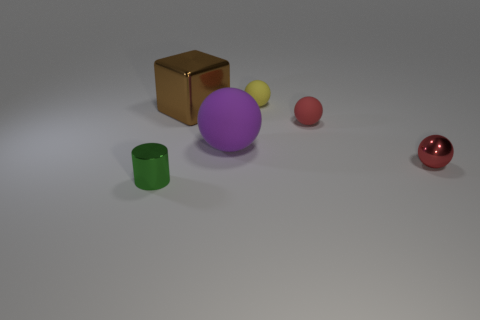What number of tiny objects have the same material as the big block?
Your answer should be very brief. 2. Are there fewer things than tiny green metallic cylinders?
Offer a terse response. No. Is the color of the small matte sphere in front of the small yellow matte thing the same as the metal sphere?
Offer a terse response. Yes. How many purple rubber spheres are on the right side of the small matte sphere in front of the object that is behind the big brown cube?
Offer a terse response. 0. There is a large shiny cube; how many rubber things are behind it?
Keep it short and to the point. 1. The other shiny thing that is the same shape as the yellow object is what color?
Provide a short and direct response. Red. What is the material of the tiny thing that is in front of the purple sphere and on the right side of the metallic cylinder?
Offer a very short reply. Metal. Does the ball behind the brown thing have the same size as the small red matte ball?
Keep it short and to the point. Yes. What material is the brown block?
Ensure brevity in your answer.  Metal. There is a tiny metal sphere that is to the right of the block; what color is it?
Provide a succinct answer. Red. 